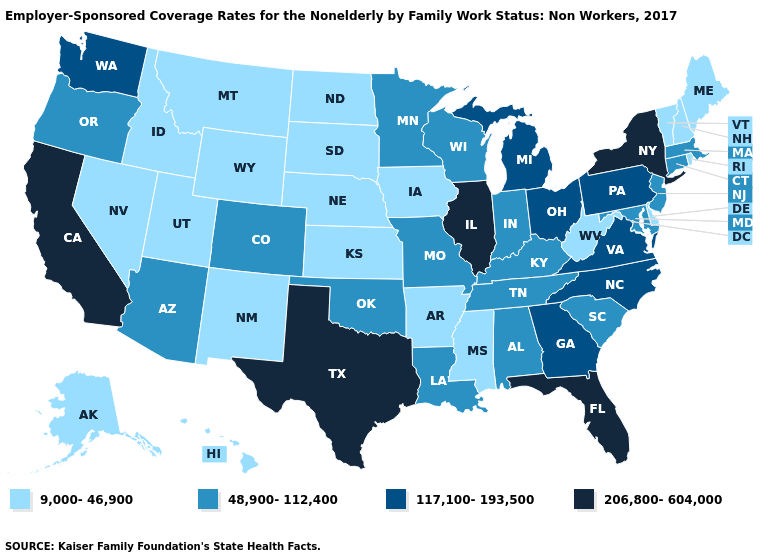How many symbols are there in the legend?
Concise answer only. 4. What is the highest value in the USA?
Write a very short answer. 206,800-604,000. Does the first symbol in the legend represent the smallest category?
Write a very short answer. Yes. Name the states that have a value in the range 206,800-604,000?
Short answer required. California, Florida, Illinois, New York, Texas. Does the map have missing data?
Be succinct. No. Name the states that have a value in the range 206,800-604,000?
Give a very brief answer. California, Florida, Illinois, New York, Texas. Name the states that have a value in the range 206,800-604,000?
Write a very short answer. California, Florida, Illinois, New York, Texas. Which states have the lowest value in the West?
Give a very brief answer. Alaska, Hawaii, Idaho, Montana, Nevada, New Mexico, Utah, Wyoming. Does the first symbol in the legend represent the smallest category?
Short answer required. Yes. Does New York have the highest value in the USA?
Write a very short answer. Yes. Does the map have missing data?
Short answer required. No. How many symbols are there in the legend?
Be succinct. 4. What is the value of Texas?
Concise answer only. 206,800-604,000. What is the highest value in the MidWest ?
Write a very short answer. 206,800-604,000. What is the value of Montana?
Give a very brief answer. 9,000-46,900. 